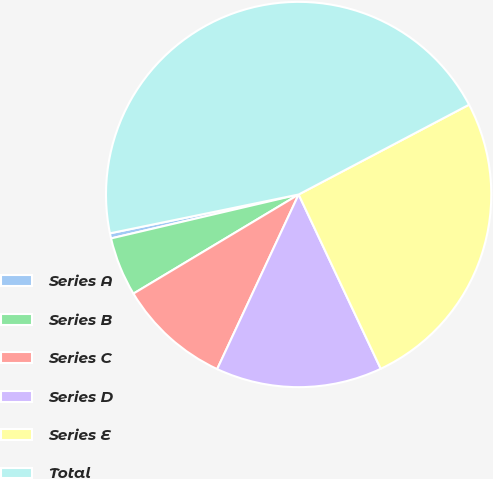Convert chart. <chart><loc_0><loc_0><loc_500><loc_500><pie_chart><fcel>Series A<fcel>Series B<fcel>Series C<fcel>Series D<fcel>Series E<fcel>Total<nl><fcel>0.43%<fcel>4.94%<fcel>9.45%<fcel>13.96%<fcel>25.71%<fcel>45.51%<nl></chart> 